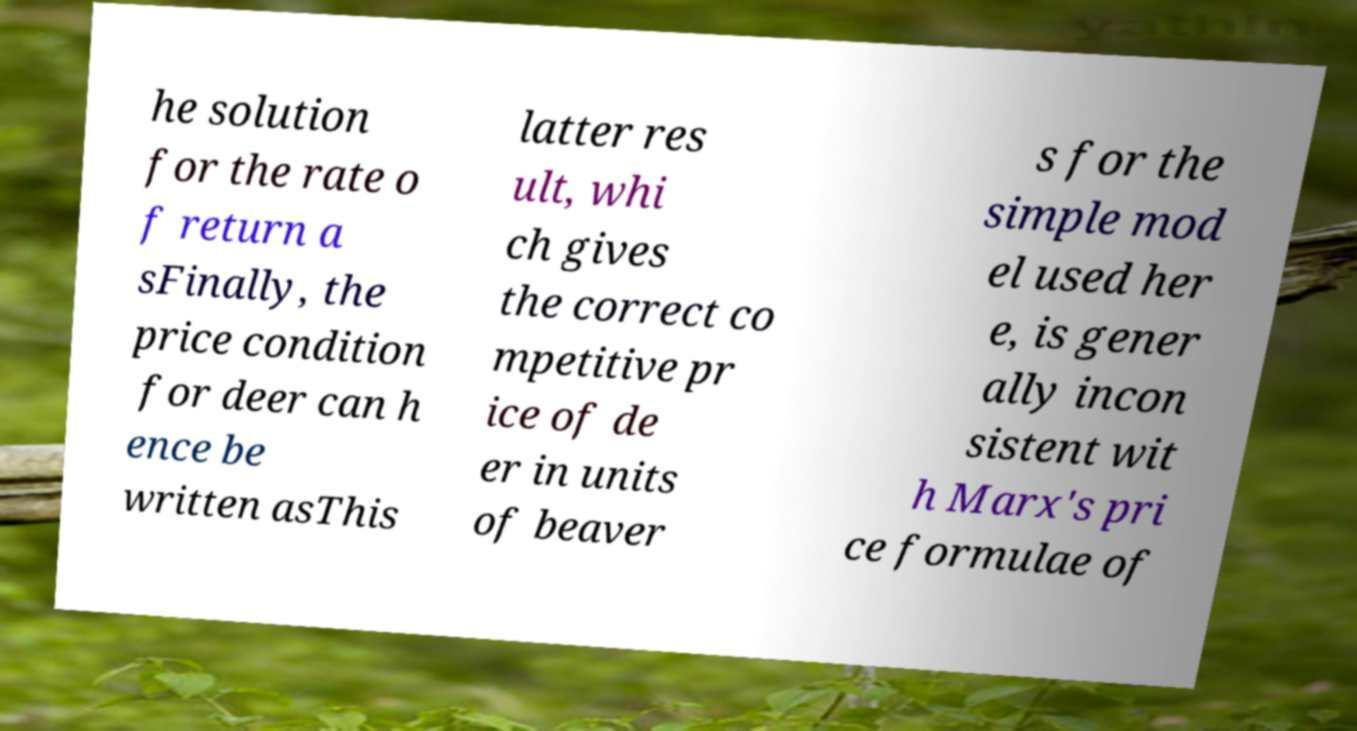Please identify and transcribe the text found in this image. he solution for the rate o f return a sFinally, the price condition for deer can h ence be written asThis latter res ult, whi ch gives the correct co mpetitive pr ice of de er in units of beaver s for the simple mod el used her e, is gener ally incon sistent wit h Marx's pri ce formulae of 